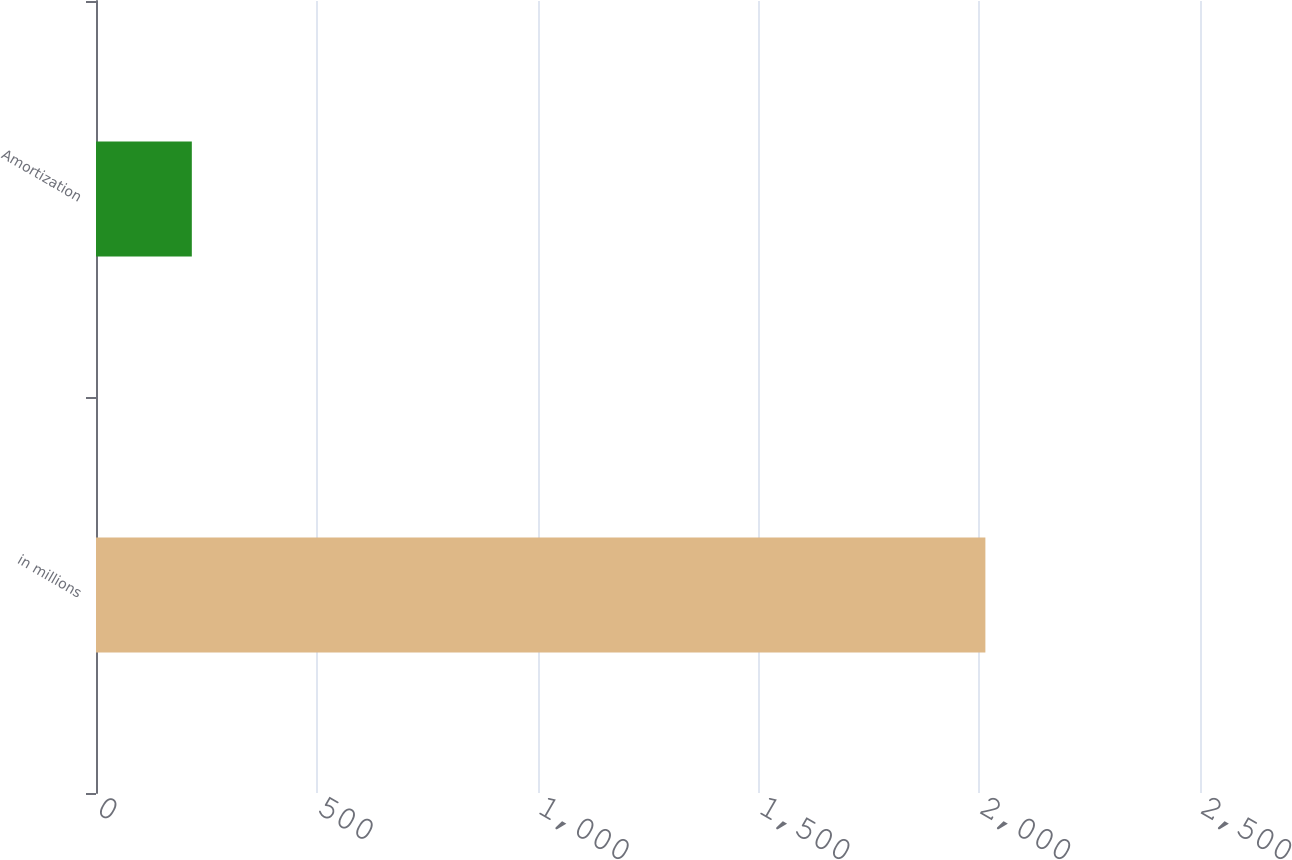<chart> <loc_0><loc_0><loc_500><loc_500><bar_chart><fcel>in millions<fcel>Amortization<nl><fcel>2014<fcel>217<nl></chart> 